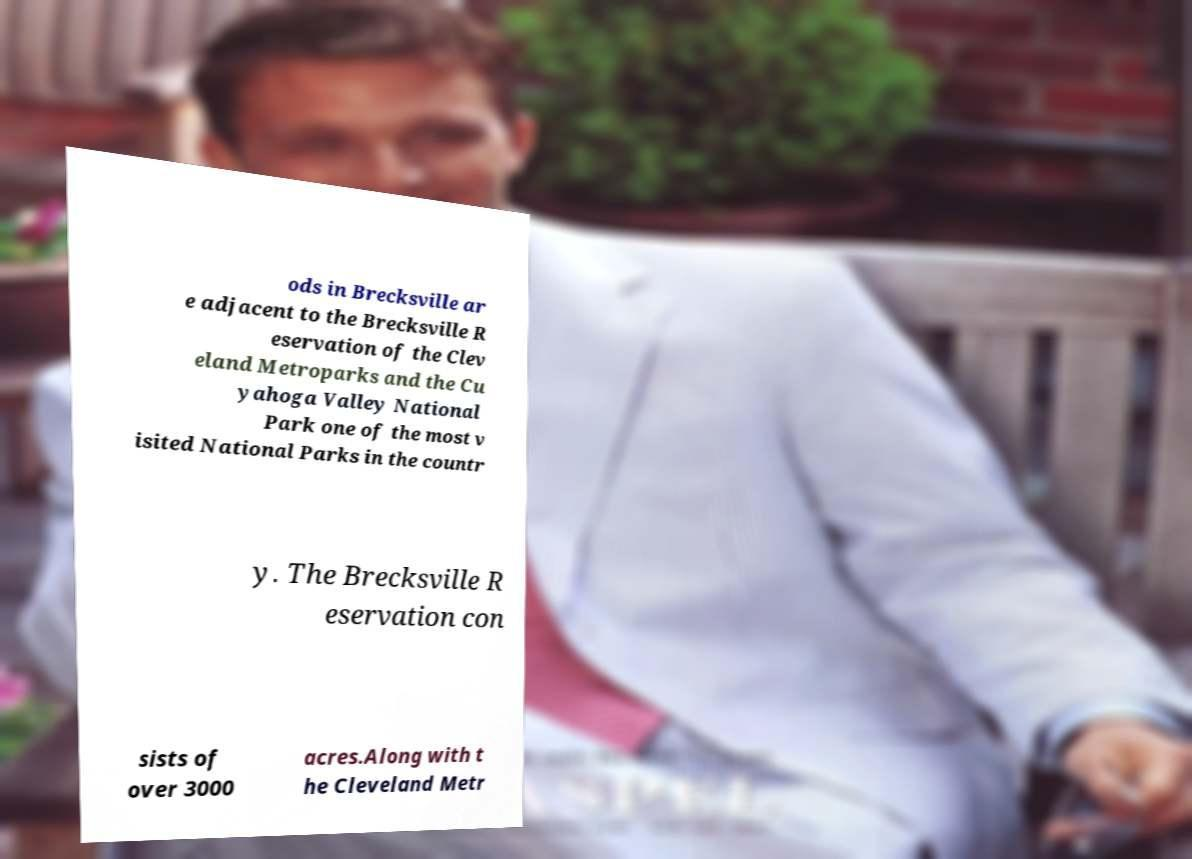For documentation purposes, I need the text within this image transcribed. Could you provide that? ods in Brecksville ar e adjacent to the Brecksville R eservation of the Clev eland Metroparks and the Cu yahoga Valley National Park one of the most v isited National Parks in the countr y. The Brecksville R eservation con sists of over 3000 acres.Along with t he Cleveland Metr 